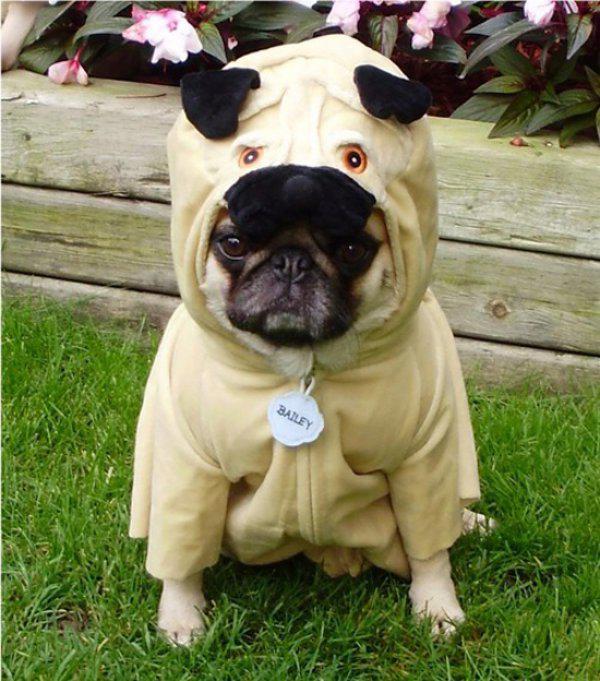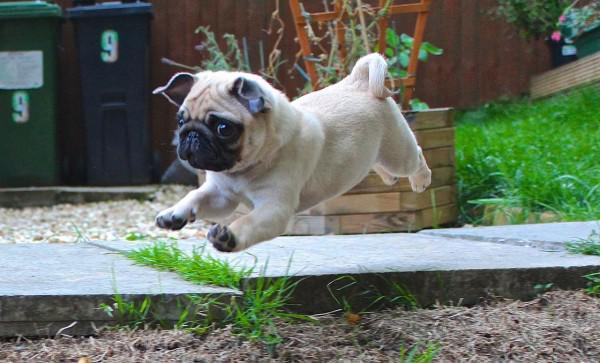The first image is the image on the left, the second image is the image on the right. For the images shown, is this caption "A dog is shown near some sheep." true? Answer yes or no. No. The first image is the image on the left, the second image is the image on the right. Evaluate the accuracy of this statement regarding the images: "Only one of the images shows a dog wearing animal-themed attire.". Is it true? Answer yes or no. Yes. 